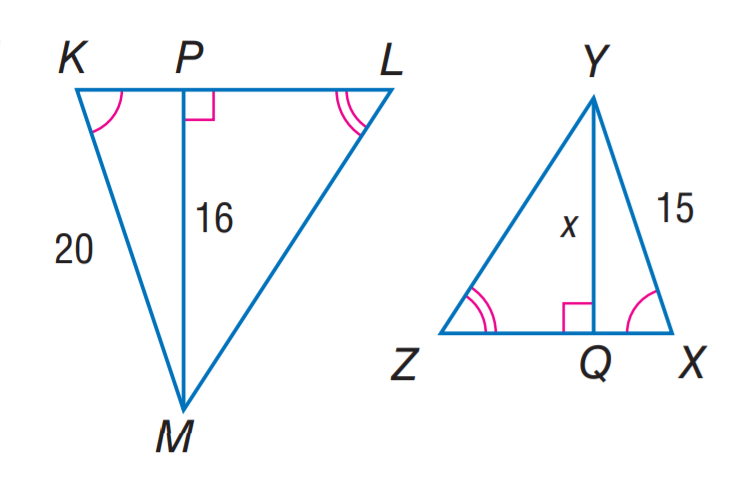Answer the mathemtical geometry problem and directly provide the correct option letter.
Question: Find x.
Choices: A: 8 B: 12 C: 15 D: 16 B 